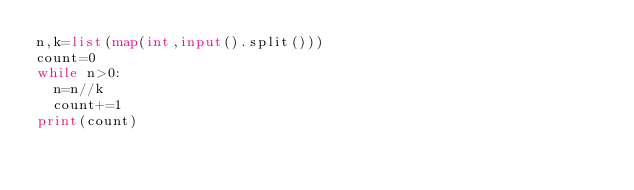<code> <loc_0><loc_0><loc_500><loc_500><_Python_>n,k=list(map(int,input().split()))
count=0
while n>0:
  n=n//k
  count+=1
print(count)</code> 